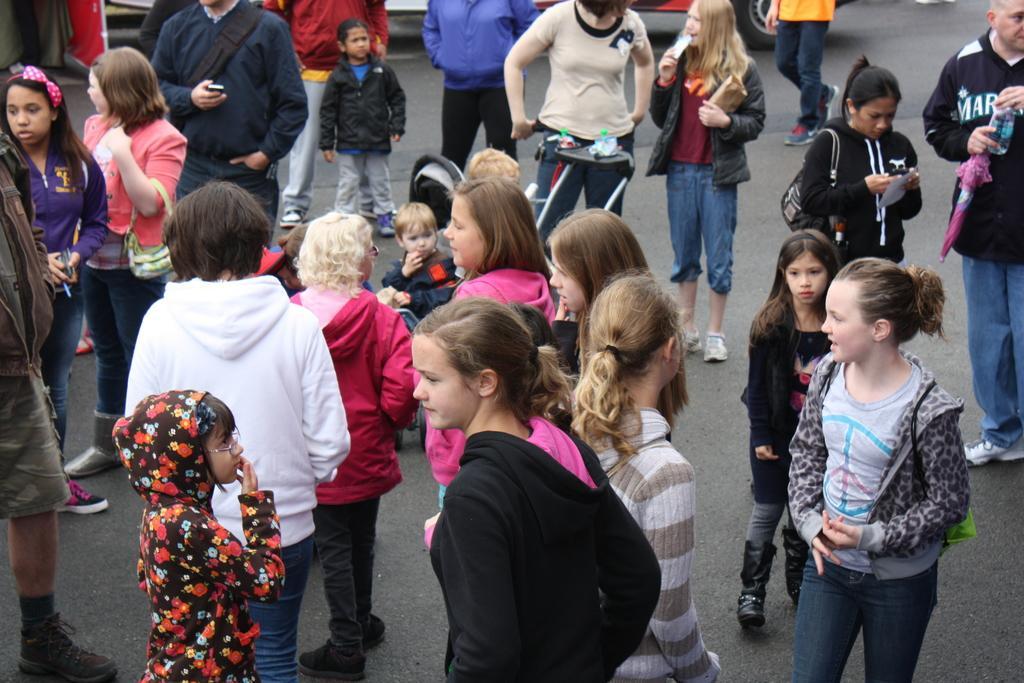Describe this image in one or two sentences. In this image there are group of people standing on the road. In the middle there is a man who is holding the trolley. In this image there are people of different age groups who are standing on the road. 